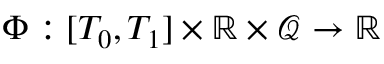Convert formula to latex. <formula><loc_0><loc_0><loc_500><loc_500>\Phi \colon [ T _ { 0 } , T _ { 1 } ] \times \mathbb { R } \times \mathcal { Q } \rightarrow \mathbb { R }</formula> 